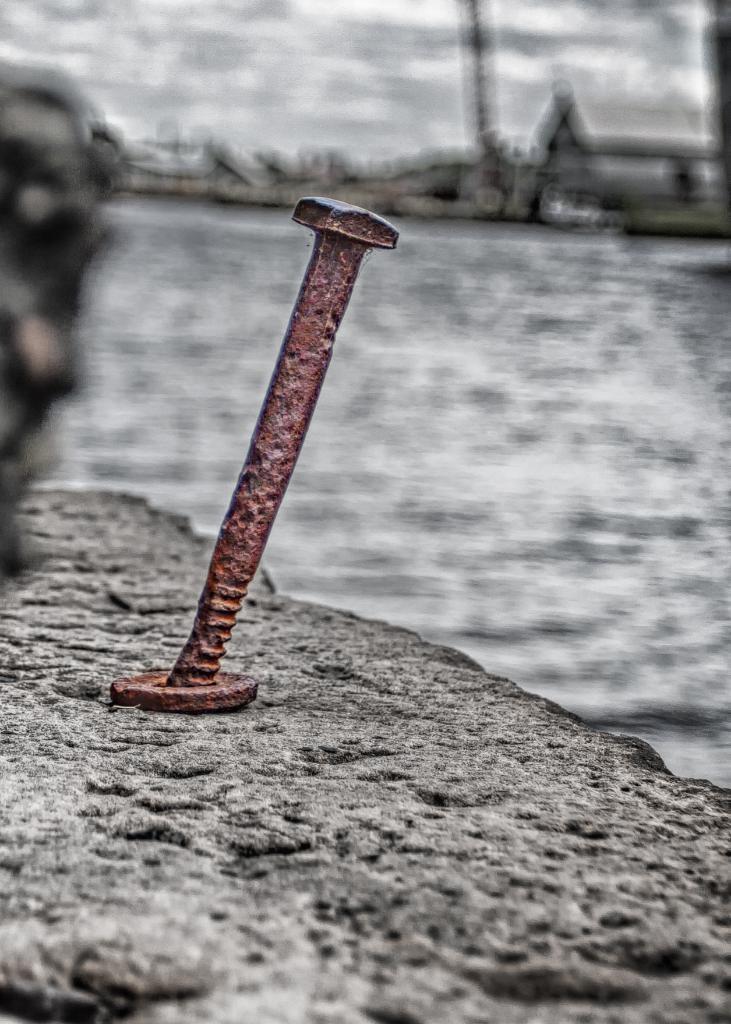Could you give a brief overview of what you see in this image? In this picture we can see an iron object. Behind the iron object, there is the blurred background. 